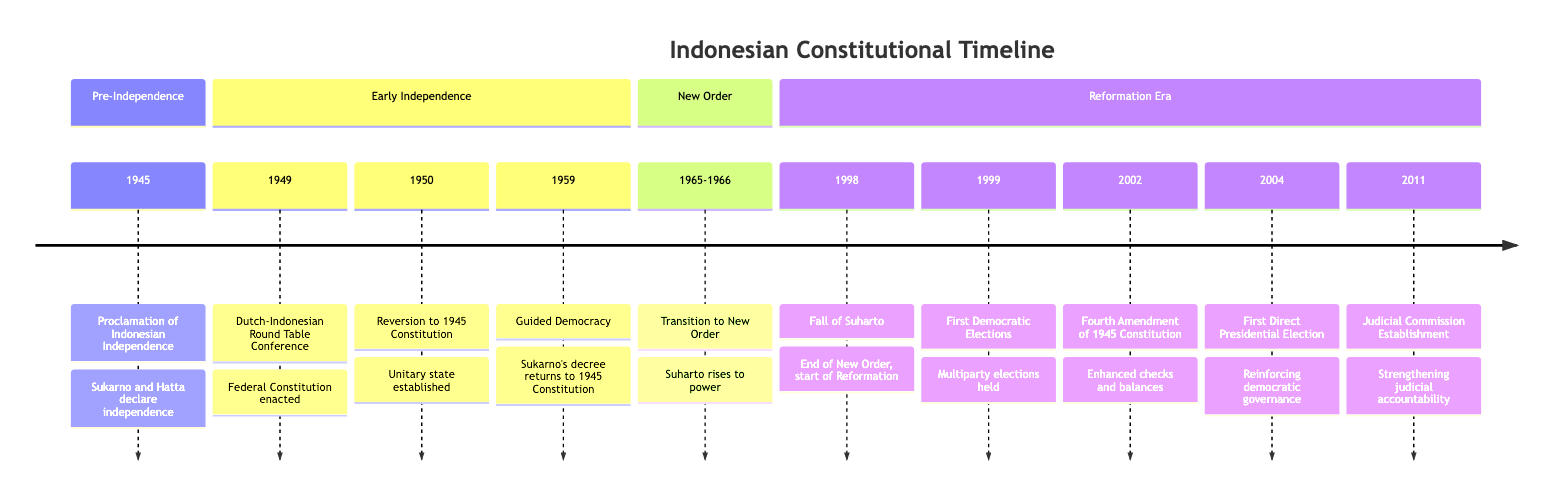What year was the Proclamation of Indonesian Independence? The diagram shows that the Proclamation of Indonesian Independence occurred in the year 1945.
Answer: 1945 What event took place in 1998? According to the timeline, the event that took place in 1998 was the Fall of Suharto.
Answer: Fall of Suharto Which constitution was in effect after the Dutch-Indonesian Round Table Conference? The timeline indicates that the Federal Constitution came into effect following the Dutch-Indonesian Round Table Conference in 1949.
Answer: Federal Constitution How many amendments to the 1945 Constitution are noted in the timeline? The timeline specifies one major amendment in 2002, referred to as the Fourth Amendment, indicating that there has been one noted constitutional amendment in this period.
Answer: One What significant political transition occurred in 1965-1966? The diagram highlights that the Transition to the New Order, where Suharto rose to power, occurred during 1965-1966.
Answer: Transition to the New Order When were the first Democratic Elections held? The timeline provides the year 1999 as the time when the first Democratic Elections were held in Indonesia.
Answer: 1999 What event marks the beginning of the Reformation era? The timeline explicitly states that the resignation of President Suharto in 1998 marks the beginning of the Reformation era.
Answer: Resignation of President Suharto What constitutional body was established in 2002? The timeline notes that in 2002, the Regional Representative Council was established as part of the Fourth Amendment to the 1945 Constitution.
Answer: Regional Representative Council What political era does the term "Guided Democracy" refer to? The timeline indicates that "Guided Democracy" refers to the era initiated by Sukarno's decree in 1959, marking a significant shift in governance.
Answer: Guided Democracy 